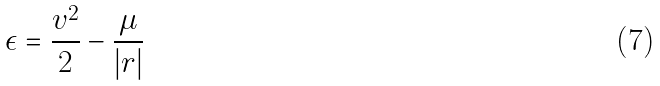<formula> <loc_0><loc_0><loc_500><loc_500>\epsilon = \frac { v ^ { 2 } } { 2 } - \frac { \mu } { | r | }</formula> 